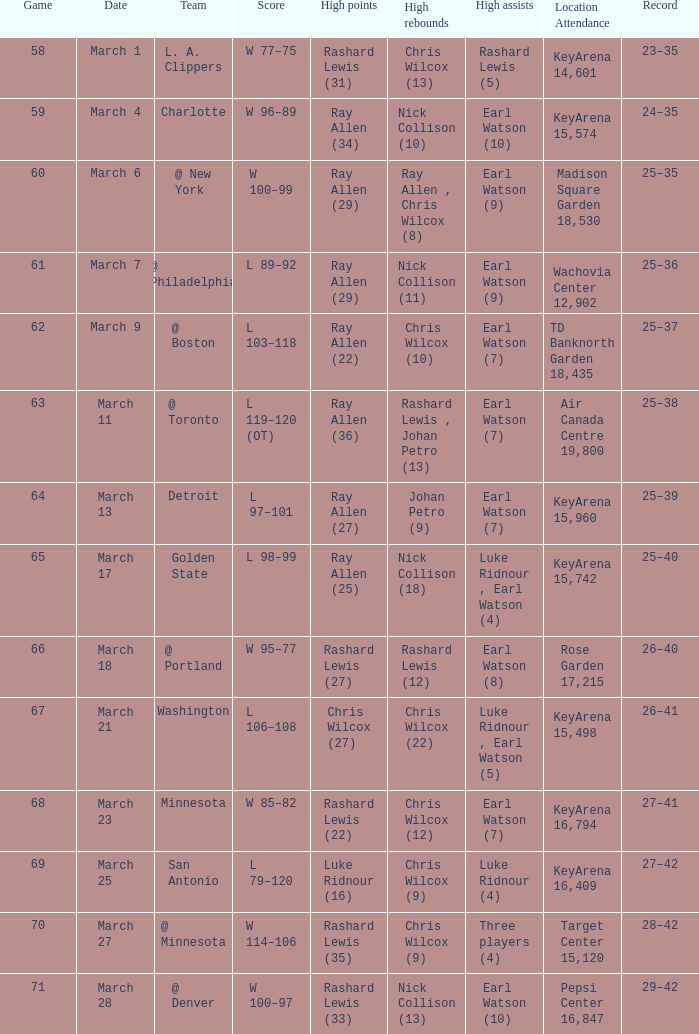Who scored the highest points in the match on march 7? Ray Allen (29). 